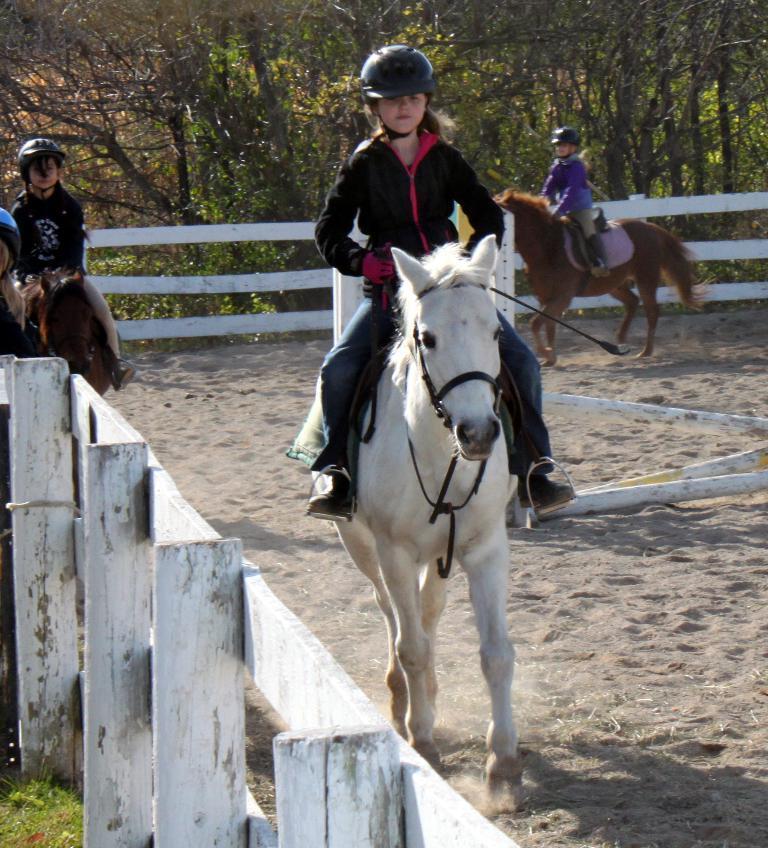In one or two sentences, can you explain what this image depicts? In this picture we can see three persons riding horses, at the bottom there is sand, these people wore helmets, in the background there are some trees, at the left bottom there is grass. 